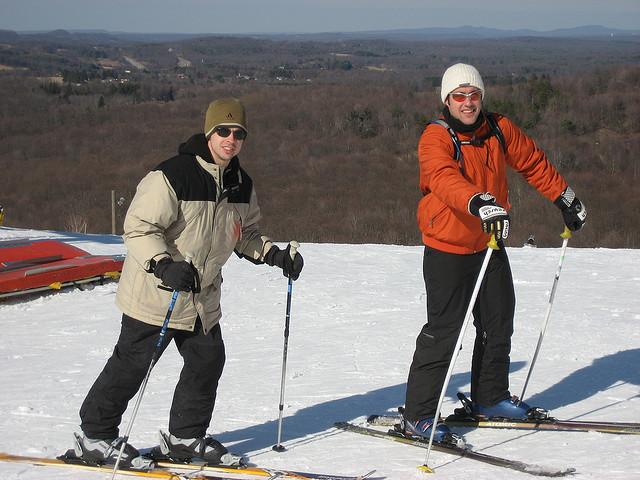Are they downhill skiing?
Short answer required. No. Are both men wearing gloves?
Write a very short answer. Yes. Do the trees have snow on them?
Concise answer only. No. Is it winter?
Quick response, please. Yes. How many people are completely visible in this picture?
Answer briefly. 2. What is on the ground?
Give a very brief answer. Snow. How many people are in the picture?
Be succinct. 2. Is the man in front dressed warmly?
Give a very brief answer. Yes. 